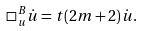<formula> <loc_0><loc_0><loc_500><loc_500>\square _ { u } ^ { B } \dot { u } = t ( 2 m + 2 ) \dot { u } .</formula> 